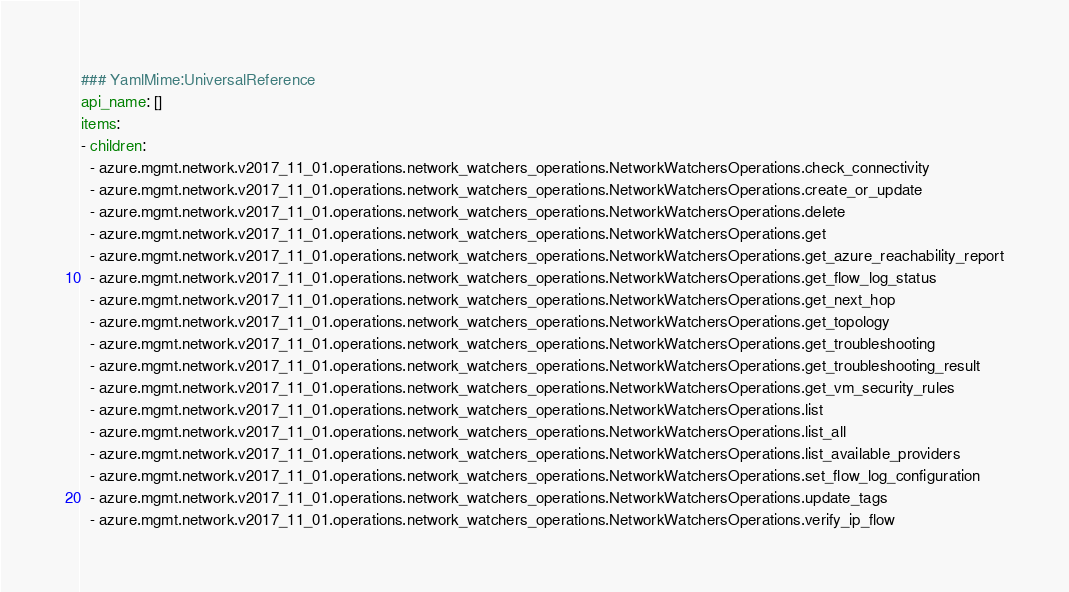Convert code to text. <code><loc_0><loc_0><loc_500><loc_500><_YAML_>### YamlMime:UniversalReference
api_name: []
items:
- children:
  - azure.mgmt.network.v2017_11_01.operations.network_watchers_operations.NetworkWatchersOperations.check_connectivity
  - azure.mgmt.network.v2017_11_01.operations.network_watchers_operations.NetworkWatchersOperations.create_or_update
  - azure.mgmt.network.v2017_11_01.operations.network_watchers_operations.NetworkWatchersOperations.delete
  - azure.mgmt.network.v2017_11_01.operations.network_watchers_operations.NetworkWatchersOperations.get
  - azure.mgmt.network.v2017_11_01.operations.network_watchers_operations.NetworkWatchersOperations.get_azure_reachability_report
  - azure.mgmt.network.v2017_11_01.operations.network_watchers_operations.NetworkWatchersOperations.get_flow_log_status
  - azure.mgmt.network.v2017_11_01.operations.network_watchers_operations.NetworkWatchersOperations.get_next_hop
  - azure.mgmt.network.v2017_11_01.operations.network_watchers_operations.NetworkWatchersOperations.get_topology
  - azure.mgmt.network.v2017_11_01.operations.network_watchers_operations.NetworkWatchersOperations.get_troubleshooting
  - azure.mgmt.network.v2017_11_01.operations.network_watchers_operations.NetworkWatchersOperations.get_troubleshooting_result
  - azure.mgmt.network.v2017_11_01.operations.network_watchers_operations.NetworkWatchersOperations.get_vm_security_rules
  - azure.mgmt.network.v2017_11_01.operations.network_watchers_operations.NetworkWatchersOperations.list
  - azure.mgmt.network.v2017_11_01.operations.network_watchers_operations.NetworkWatchersOperations.list_all
  - azure.mgmt.network.v2017_11_01.operations.network_watchers_operations.NetworkWatchersOperations.list_available_providers
  - azure.mgmt.network.v2017_11_01.operations.network_watchers_operations.NetworkWatchersOperations.set_flow_log_configuration
  - azure.mgmt.network.v2017_11_01.operations.network_watchers_operations.NetworkWatchersOperations.update_tags
  - azure.mgmt.network.v2017_11_01.operations.network_watchers_operations.NetworkWatchersOperations.verify_ip_flow</code> 